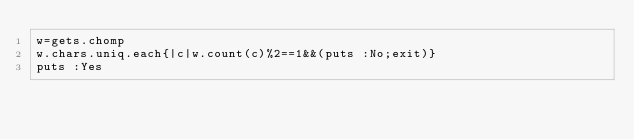Convert code to text. <code><loc_0><loc_0><loc_500><loc_500><_Ruby_>w=gets.chomp
w.chars.uniq.each{|c|w.count(c)%2==1&&(puts :No;exit)}
puts :Yes
</code> 